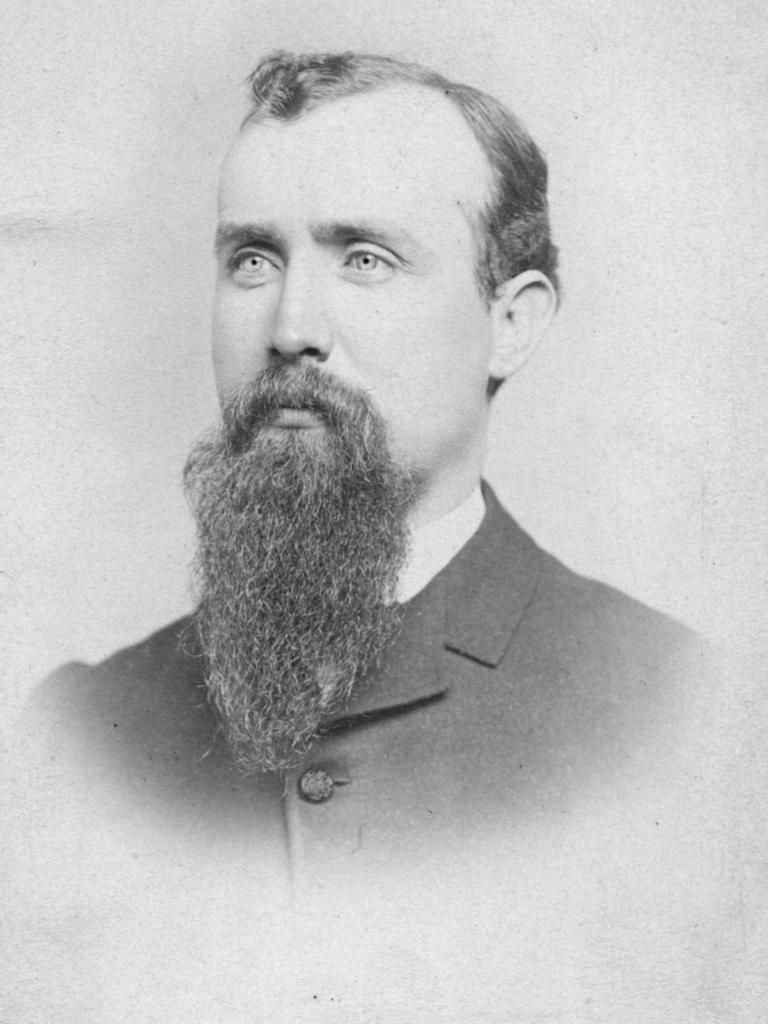What is the color scheme of the picture? The picture is black and white. Can you describe the main subject in the image? There is a man in the picture. What type of lamp is present in the picture? There is no lamp present in the picture; it is a black and white image featuring a man. Where is the hospital located in the image? There is no hospital present in the image; it only features a man in a black and white setting. 